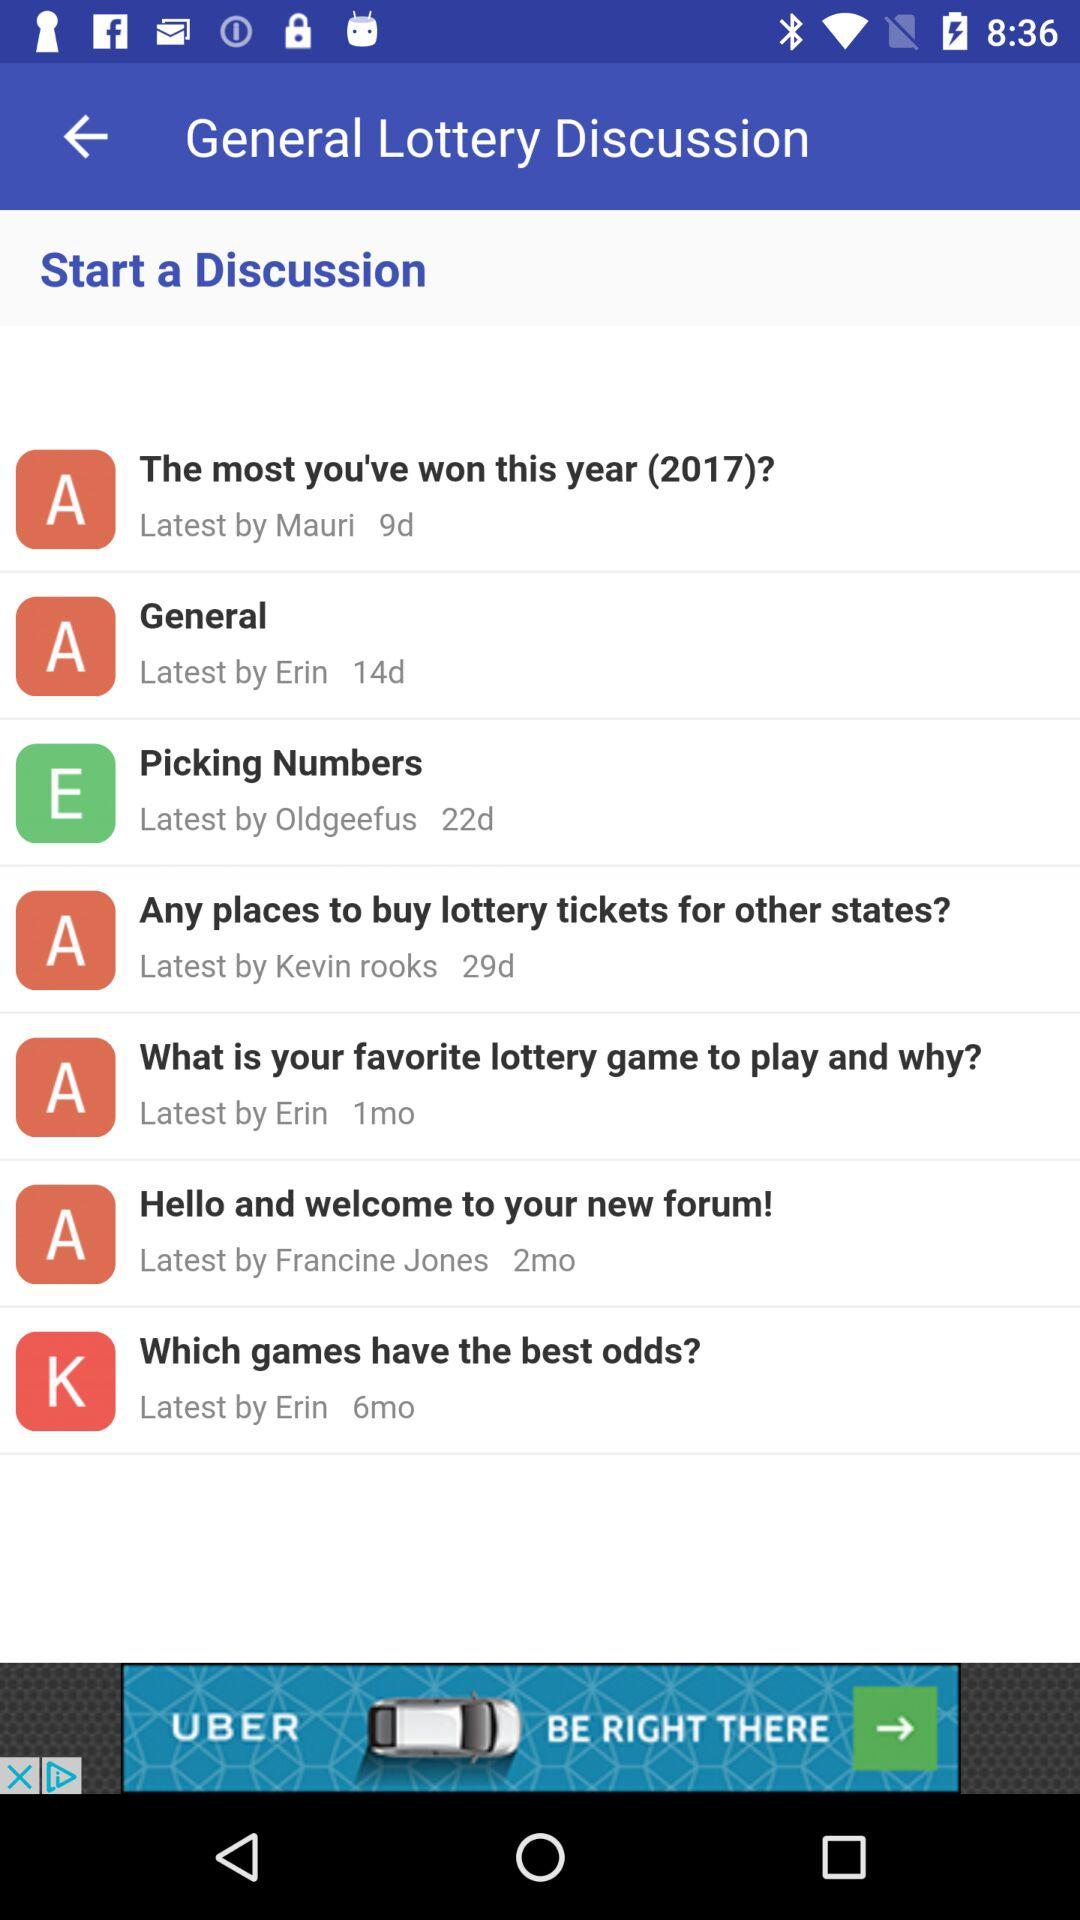Who started the discussion on the topic "General"? The discussion on the topic "General" was started by Erin. 